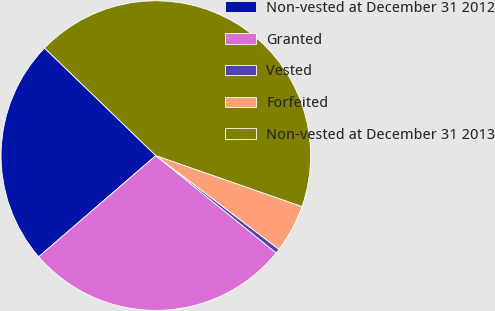Convert chart. <chart><loc_0><loc_0><loc_500><loc_500><pie_chart><fcel>Non-vested at December 31 2012<fcel>Granted<fcel>Vested<fcel>Forfeited<fcel>Non-vested at December 31 2013<nl><fcel>23.57%<fcel>27.83%<fcel>0.47%<fcel>5.02%<fcel>43.11%<nl></chart> 